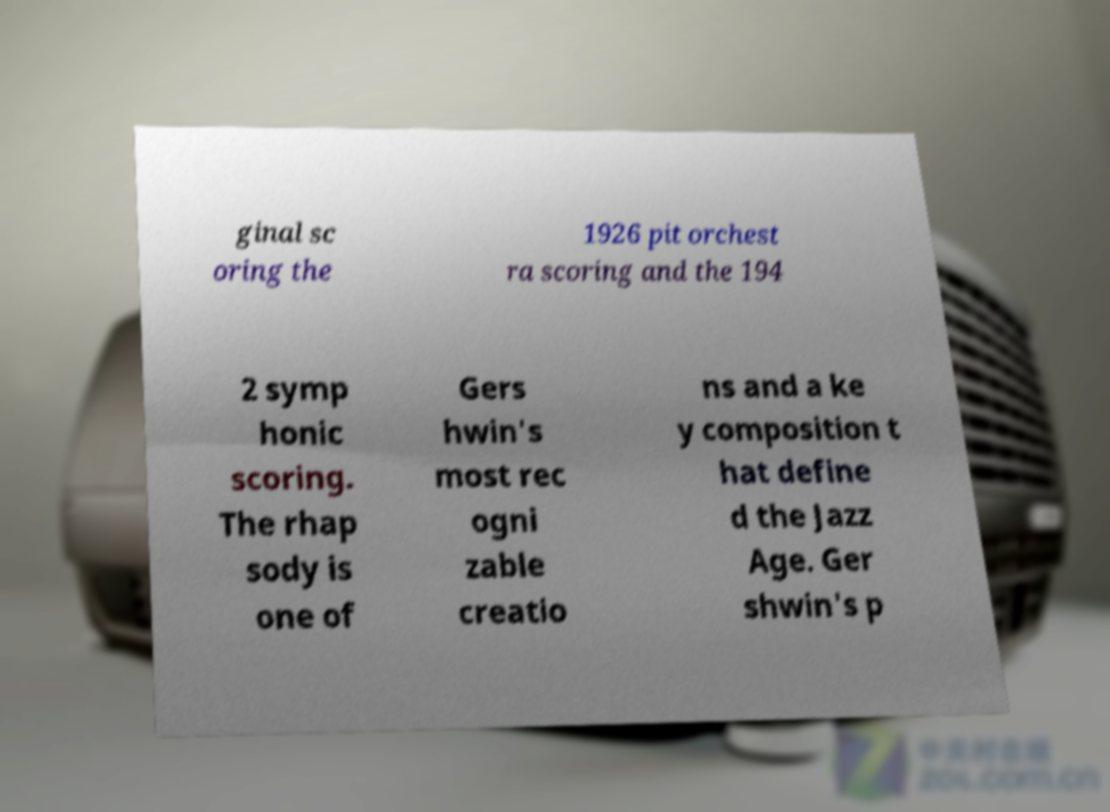Can you read and provide the text displayed in the image?This photo seems to have some interesting text. Can you extract and type it out for me? ginal sc oring the 1926 pit orchest ra scoring and the 194 2 symp honic scoring. The rhap sody is one of Gers hwin's most rec ogni zable creatio ns and a ke y composition t hat define d the Jazz Age. Ger shwin's p 